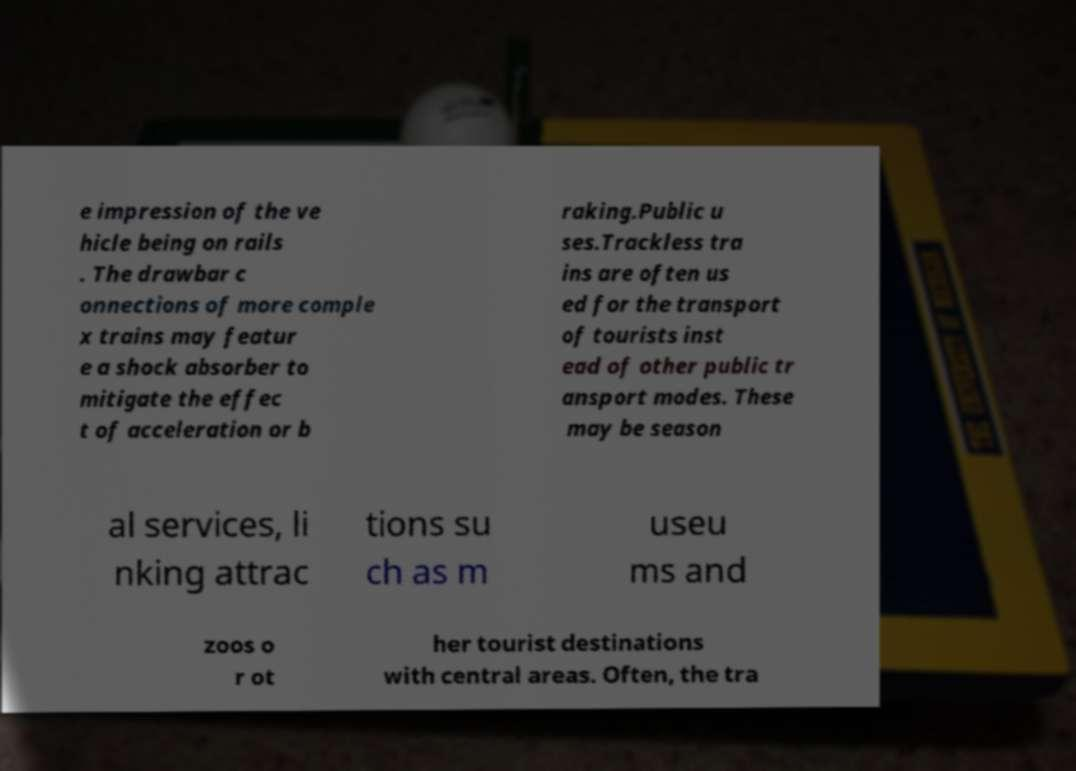Please identify and transcribe the text found in this image. e impression of the ve hicle being on rails . The drawbar c onnections of more comple x trains may featur e a shock absorber to mitigate the effec t of acceleration or b raking.Public u ses.Trackless tra ins are often us ed for the transport of tourists inst ead of other public tr ansport modes. These may be season al services, li nking attrac tions su ch as m useu ms and zoos o r ot her tourist destinations with central areas. Often, the tra 